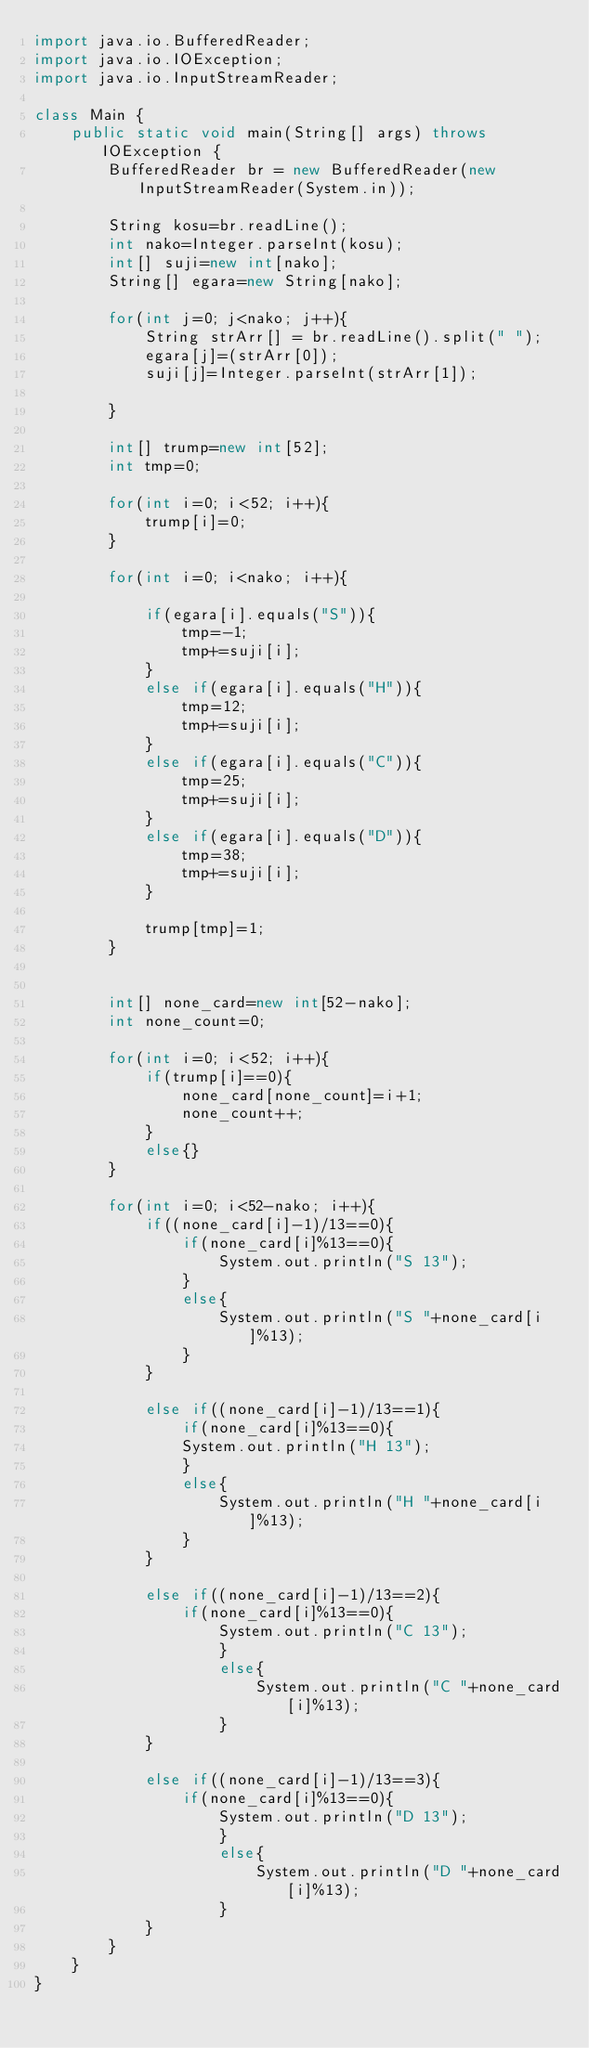Convert code to text. <code><loc_0><loc_0><loc_500><loc_500><_Java_>import java.io.BufferedReader;
import java.io.IOException;
import java.io.InputStreamReader;

class Main {
	public static void main(String[] args) throws IOException {
		BufferedReader br = new BufferedReader(new InputStreamReader(System.in));

		String kosu=br.readLine();
		int nako=Integer.parseInt(kosu);
		int[] suji=new int[nako];
		String[] egara=new String[nako];

		for(int j=0; j<nako; j++){
			String strArr[] = br.readLine().split(" ");
			egara[j]=(strArr[0]);
			suji[j]=Integer.parseInt(strArr[1]);
			
		}

		int[] trump=new int[52];
		int tmp=0;

		for(int i=0; i<52; i++){
			trump[i]=0;
		}

		for(int i=0; i<nako; i++){

			if(egara[i].equals("S")){
				tmp=-1;
				tmp+=suji[i];
			}
			else if(egara[i].equals("H")){
				tmp=12;
				tmp+=suji[i];
			}
			else if(egara[i].equals("C")){
				tmp=25;
				tmp+=suji[i];
			}
			else if(egara[i].equals("D")){
				tmp=38;
				tmp+=suji[i];
			}

			trump[tmp]=1;
		}


		int[] none_card=new int[52-nako];
		int none_count=0;

		for(int i=0; i<52; i++){
			if(trump[i]==0){
				none_card[none_count]=i+1;
				none_count++;
			}
			else{}
		}

		for(int i=0; i<52-nako; i++){
			if((none_card[i]-1)/13==0){
				if(none_card[i]%13==0){
					System.out.println("S 13");
				}
				else{
					System.out.println("S "+none_card[i]%13);
				}
			}

			else if((none_card[i]-1)/13==1){
				if(none_card[i]%13==0){
				System.out.println("H 13");
				}
				else{
					System.out.println("H "+none_card[i]%13);
				}
			}

			else if((none_card[i]-1)/13==2){
				if(none_card[i]%13==0){
					System.out.println("C 13");
					}
					else{
						System.out.println("C "+none_card[i]%13);
					}
			}

			else if((none_card[i]-1)/13==3){
				if(none_card[i]%13==0){
					System.out.println("D 13");
					}
					else{
						System.out.println("D "+none_card[i]%13);
					}
			}
		}
	}
}</code> 